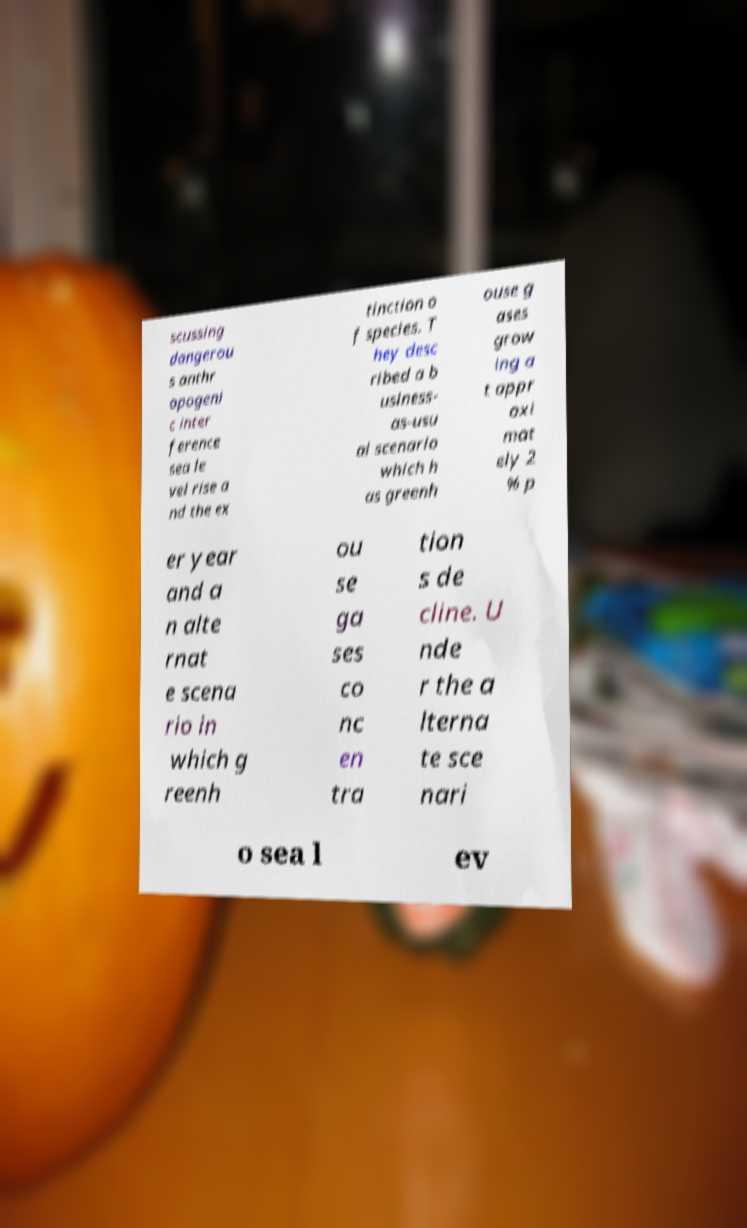I need the written content from this picture converted into text. Can you do that? scussing dangerou s anthr opogeni c inter ference sea le vel rise a nd the ex tinction o f species. T hey desc ribed a b usiness- as-usu al scenario which h as greenh ouse g ases grow ing a t appr oxi mat ely 2 % p er year and a n alte rnat e scena rio in which g reenh ou se ga ses co nc en tra tion s de cline. U nde r the a lterna te sce nari o sea l ev 